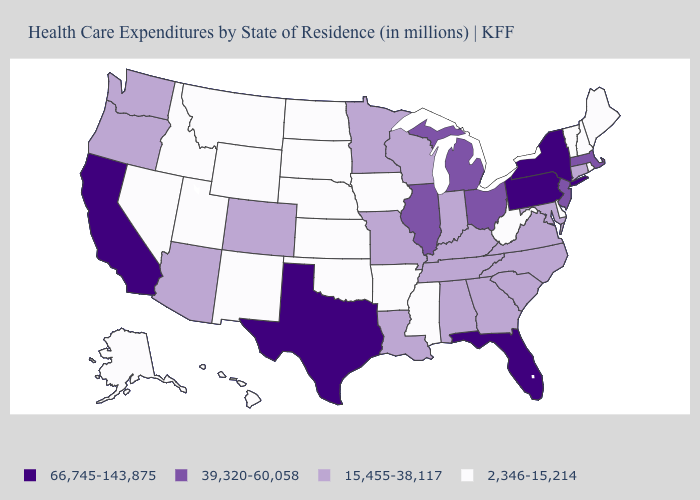Name the states that have a value in the range 39,320-60,058?
Quick response, please. Illinois, Massachusetts, Michigan, New Jersey, Ohio. What is the highest value in the MidWest ?
Quick response, please. 39,320-60,058. Name the states that have a value in the range 15,455-38,117?
Answer briefly. Alabama, Arizona, Colorado, Connecticut, Georgia, Indiana, Kentucky, Louisiana, Maryland, Minnesota, Missouri, North Carolina, Oregon, South Carolina, Tennessee, Virginia, Washington, Wisconsin. Among the states that border Virginia , does West Virginia have the lowest value?
Concise answer only. Yes. How many symbols are there in the legend?
Answer briefly. 4. What is the highest value in states that border Minnesota?
Keep it brief. 15,455-38,117. What is the value of Texas?
Concise answer only. 66,745-143,875. What is the value of Kansas?
Quick response, please. 2,346-15,214. Name the states that have a value in the range 39,320-60,058?
Answer briefly. Illinois, Massachusetts, Michigan, New Jersey, Ohio. Name the states that have a value in the range 2,346-15,214?
Be succinct. Alaska, Arkansas, Delaware, Hawaii, Idaho, Iowa, Kansas, Maine, Mississippi, Montana, Nebraska, Nevada, New Hampshire, New Mexico, North Dakota, Oklahoma, Rhode Island, South Dakota, Utah, Vermont, West Virginia, Wyoming. What is the value of South Carolina?
Quick response, please. 15,455-38,117. Does the first symbol in the legend represent the smallest category?
Short answer required. No. Name the states that have a value in the range 66,745-143,875?
Short answer required. California, Florida, New York, Pennsylvania, Texas. Which states have the lowest value in the South?
Keep it brief. Arkansas, Delaware, Mississippi, Oklahoma, West Virginia. Does the first symbol in the legend represent the smallest category?
Short answer required. No. 